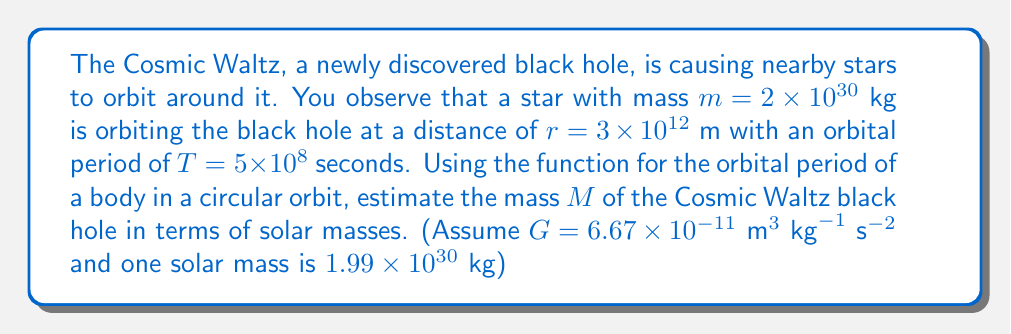Give your solution to this math problem. To solve this problem, we'll use the formula for the orbital period of a body in a circular orbit:

$$T = 2\pi \sqrt{\frac{r^3}{GM}}$$

Where:
$T$ is the orbital period
$r$ is the orbital radius
$G$ is the gravitational constant
$M$ is the mass of the central body (in this case, the black hole)

1) First, we'll rearrange the equation to solve for $M$:

   $$M = \frac{4\pi^2r^3}{GT^2}$$

2) Now, let's substitute the known values:

   $$M = \frac{4\pi^2(3 \times 10^{12} \text{ m})^3}{(6.67 \times 10^{-11} \text{ m}^3 \text{ kg}^{-1} \text{ s}^{-2})(5 \times 10^{8} \text{ s})^2}$$

3) Let's calculate this step by step:

   $$M = \frac{4\pi^2 \times 27 \times 10^{36}}{6.67 \times 10^{-11} \times 25 \times 10^{16}}$$

   $$M = \frac{4\pi^2 \times 27}{6.67 \times 25} \times 10^{20} \text{ kg}$$

   $$M \approx 1.92 \times 10^{21} \text{ kg}$$

4) To express this in terms of solar masses, we divide by the mass of the Sun:

   $$\text{Solar Masses} = \frac{1.92 \times 10^{21} \text{ kg}}{1.99 \times 10^{30} \text{ kg}} \approx 9.65 \times 10^{-10}$$

5) This is a very small fraction, so let's express it as a multiple of $10^{-10}$ solar masses:

   $$9.65 \times 10^{-10} \text{ solar masses} = 0.965 \times 10^{-9} \text{ solar masses}$$
Answer: $0.965 \times 10^{-9}$ solar masses 